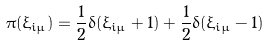<formula> <loc_0><loc_0><loc_500><loc_500>\pi ( \xi _ { i \mu } ) = \frac { 1 } { 2 } \delta ( \xi _ { i \mu } + 1 ) + \frac { 1 } { 2 } \delta ( \xi _ { i \mu } - 1 )</formula> 